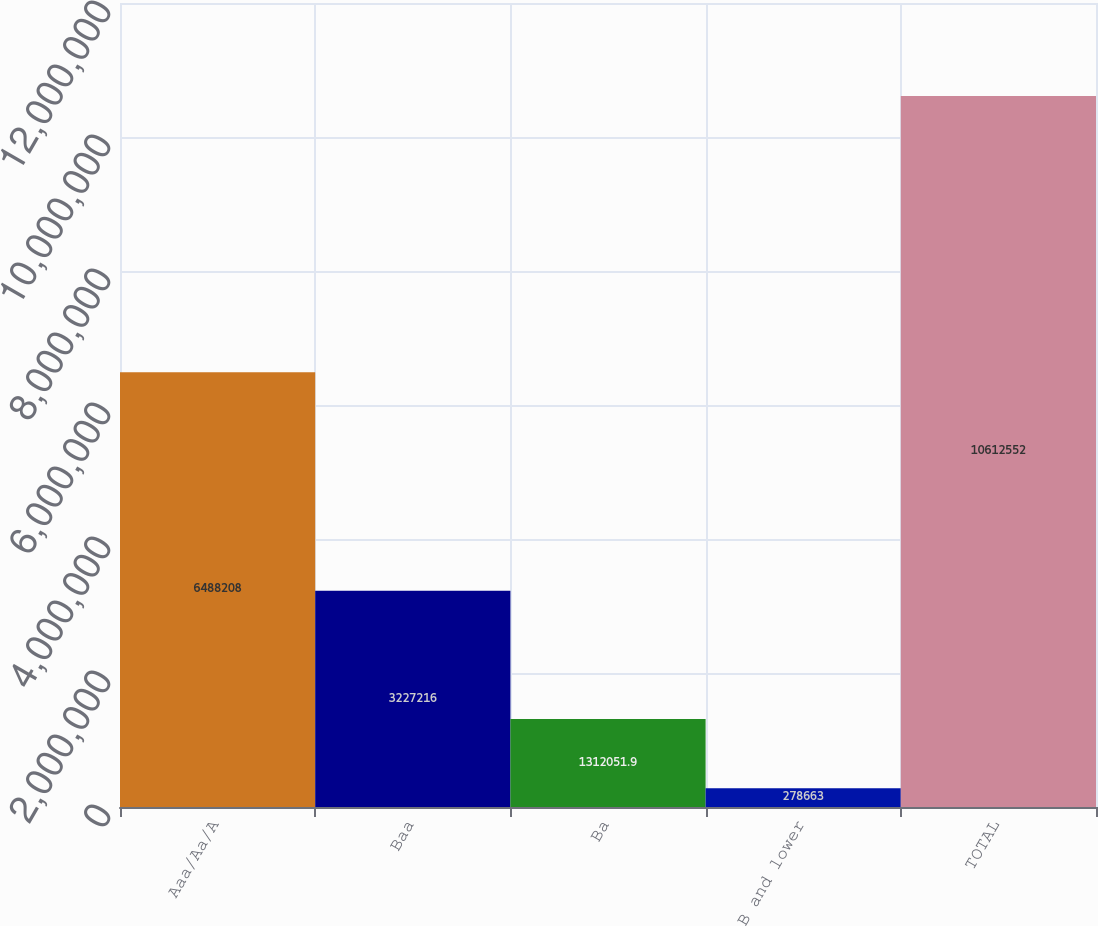<chart> <loc_0><loc_0><loc_500><loc_500><bar_chart><fcel>Aaa/Aa/A<fcel>Baa<fcel>Ba<fcel>B and lower<fcel>TOTAL<nl><fcel>6.48821e+06<fcel>3.22722e+06<fcel>1.31205e+06<fcel>278663<fcel>1.06126e+07<nl></chart> 